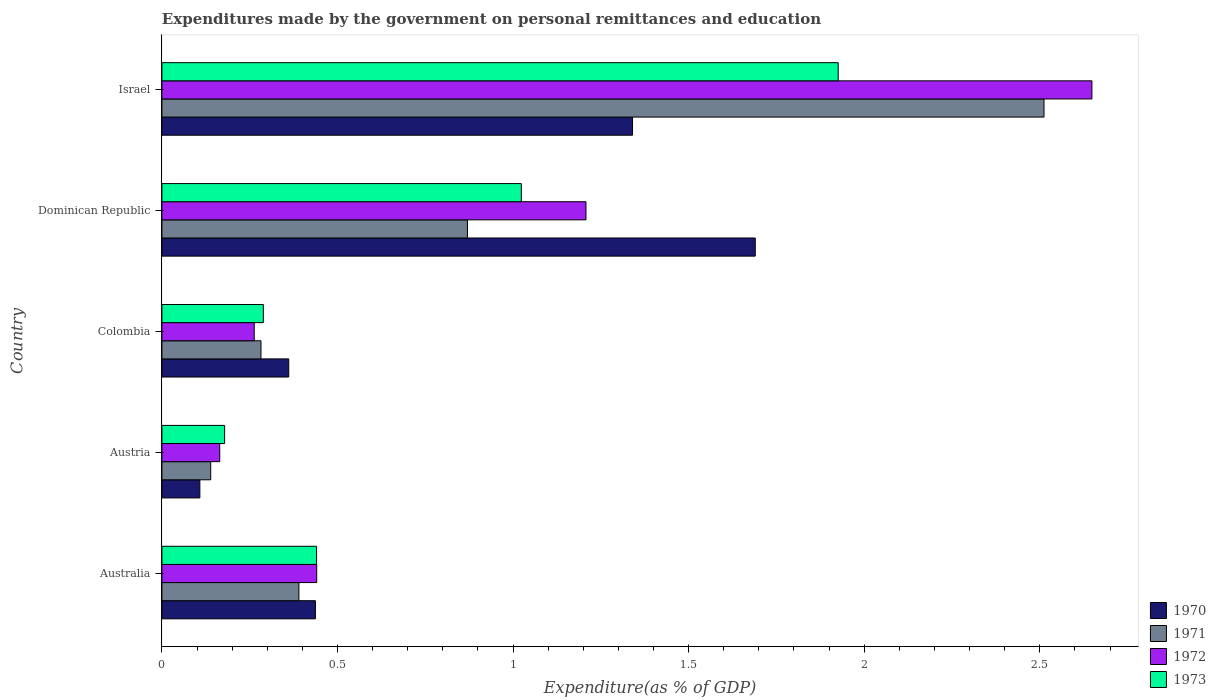How many groups of bars are there?
Keep it short and to the point. 5. Are the number of bars per tick equal to the number of legend labels?
Provide a succinct answer. Yes. How many bars are there on the 3rd tick from the top?
Provide a succinct answer. 4. How many bars are there on the 5th tick from the bottom?
Ensure brevity in your answer.  4. What is the label of the 1st group of bars from the top?
Offer a terse response. Israel. In how many cases, is the number of bars for a given country not equal to the number of legend labels?
Ensure brevity in your answer.  0. What is the expenditures made by the government on personal remittances and education in 1973 in Colombia?
Provide a short and direct response. 0.29. Across all countries, what is the maximum expenditures made by the government on personal remittances and education in 1973?
Your response must be concise. 1.93. Across all countries, what is the minimum expenditures made by the government on personal remittances and education in 1972?
Make the answer very short. 0.16. In which country was the expenditures made by the government on personal remittances and education in 1970 minimum?
Make the answer very short. Austria. What is the total expenditures made by the government on personal remittances and education in 1973 in the graph?
Your response must be concise. 3.86. What is the difference between the expenditures made by the government on personal remittances and education in 1971 in Austria and that in Israel?
Offer a very short reply. -2.37. What is the difference between the expenditures made by the government on personal remittances and education in 1973 in Australia and the expenditures made by the government on personal remittances and education in 1970 in Colombia?
Your answer should be very brief. 0.08. What is the average expenditures made by the government on personal remittances and education in 1973 per country?
Your answer should be compact. 0.77. What is the difference between the expenditures made by the government on personal remittances and education in 1971 and expenditures made by the government on personal remittances and education in 1970 in Austria?
Your answer should be very brief. 0.03. In how many countries, is the expenditures made by the government on personal remittances and education in 1972 greater than 0.9 %?
Offer a terse response. 2. What is the ratio of the expenditures made by the government on personal remittances and education in 1970 in Australia to that in Israel?
Provide a short and direct response. 0.33. Is the difference between the expenditures made by the government on personal remittances and education in 1971 in Australia and Dominican Republic greater than the difference between the expenditures made by the government on personal remittances and education in 1970 in Australia and Dominican Republic?
Offer a terse response. Yes. What is the difference between the highest and the second highest expenditures made by the government on personal remittances and education in 1971?
Make the answer very short. 1.64. What is the difference between the highest and the lowest expenditures made by the government on personal remittances and education in 1971?
Provide a short and direct response. 2.37. Is the sum of the expenditures made by the government on personal remittances and education in 1970 in Austria and Dominican Republic greater than the maximum expenditures made by the government on personal remittances and education in 1971 across all countries?
Your answer should be compact. No. Is it the case that in every country, the sum of the expenditures made by the government on personal remittances and education in 1971 and expenditures made by the government on personal remittances and education in 1970 is greater than the expenditures made by the government on personal remittances and education in 1972?
Your response must be concise. Yes. What is the difference between two consecutive major ticks on the X-axis?
Provide a short and direct response. 0.5. Are the values on the major ticks of X-axis written in scientific E-notation?
Give a very brief answer. No. Does the graph contain any zero values?
Offer a very short reply. No. Does the graph contain grids?
Your response must be concise. No. How are the legend labels stacked?
Offer a terse response. Vertical. What is the title of the graph?
Ensure brevity in your answer.  Expenditures made by the government on personal remittances and education. What is the label or title of the X-axis?
Ensure brevity in your answer.  Expenditure(as % of GDP). What is the Expenditure(as % of GDP) of 1970 in Australia?
Keep it short and to the point. 0.44. What is the Expenditure(as % of GDP) in 1971 in Australia?
Offer a very short reply. 0.39. What is the Expenditure(as % of GDP) of 1972 in Australia?
Your answer should be compact. 0.44. What is the Expenditure(as % of GDP) in 1973 in Australia?
Provide a short and direct response. 0.44. What is the Expenditure(as % of GDP) of 1970 in Austria?
Give a very brief answer. 0.11. What is the Expenditure(as % of GDP) of 1971 in Austria?
Your answer should be compact. 0.14. What is the Expenditure(as % of GDP) of 1972 in Austria?
Ensure brevity in your answer.  0.16. What is the Expenditure(as % of GDP) of 1973 in Austria?
Offer a terse response. 0.18. What is the Expenditure(as % of GDP) in 1970 in Colombia?
Give a very brief answer. 0.36. What is the Expenditure(as % of GDP) of 1971 in Colombia?
Your answer should be very brief. 0.28. What is the Expenditure(as % of GDP) of 1972 in Colombia?
Give a very brief answer. 0.26. What is the Expenditure(as % of GDP) of 1973 in Colombia?
Your answer should be compact. 0.29. What is the Expenditure(as % of GDP) of 1970 in Dominican Republic?
Offer a terse response. 1.69. What is the Expenditure(as % of GDP) of 1971 in Dominican Republic?
Make the answer very short. 0.87. What is the Expenditure(as % of GDP) of 1972 in Dominican Republic?
Your answer should be compact. 1.21. What is the Expenditure(as % of GDP) in 1973 in Dominican Republic?
Give a very brief answer. 1.02. What is the Expenditure(as % of GDP) of 1970 in Israel?
Provide a short and direct response. 1.34. What is the Expenditure(as % of GDP) of 1971 in Israel?
Offer a terse response. 2.51. What is the Expenditure(as % of GDP) of 1972 in Israel?
Provide a short and direct response. 2.65. What is the Expenditure(as % of GDP) in 1973 in Israel?
Offer a terse response. 1.93. Across all countries, what is the maximum Expenditure(as % of GDP) of 1970?
Provide a short and direct response. 1.69. Across all countries, what is the maximum Expenditure(as % of GDP) of 1971?
Offer a very short reply. 2.51. Across all countries, what is the maximum Expenditure(as % of GDP) in 1972?
Ensure brevity in your answer.  2.65. Across all countries, what is the maximum Expenditure(as % of GDP) of 1973?
Provide a short and direct response. 1.93. Across all countries, what is the minimum Expenditure(as % of GDP) in 1970?
Offer a very short reply. 0.11. Across all countries, what is the minimum Expenditure(as % of GDP) in 1971?
Make the answer very short. 0.14. Across all countries, what is the minimum Expenditure(as % of GDP) of 1972?
Your response must be concise. 0.16. Across all countries, what is the minimum Expenditure(as % of GDP) in 1973?
Your answer should be very brief. 0.18. What is the total Expenditure(as % of GDP) in 1970 in the graph?
Provide a short and direct response. 3.94. What is the total Expenditure(as % of GDP) in 1971 in the graph?
Your answer should be compact. 4.19. What is the total Expenditure(as % of GDP) of 1972 in the graph?
Your answer should be compact. 4.72. What is the total Expenditure(as % of GDP) in 1973 in the graph?
Provide a short and direct response. 3.86. What is the difference between the Expenditure(as % of GDP) of 1970 in Australia and that in Austria?
Provide a short and direct response. 0.33. What is the difference between the Expenditure(as % of GDP) in 1971 in Australia and that in Austria?
Offer a very short reply. 0.25. What is the difference between the Expenditure(as % of GDP) of 1972 in Australia and that in Austria?
Keep it short and to the point. 0.28. What is the difference between the Expenditure(as % of GDP) of 1973 in Australia and that in Austria?
Give a very brief answer. 0.26. What is the difference between the Expenditure(as % of GDP) in 1970 in Australia and that in Colombia?
Your answer should be very brief. 0.08. What is the difference between the Expenditure(as % of GDP) of 1971 in Australia and that in Colombia?
Your answer should be very brief. 0.11. What is the difference between the Expenditure(as % of GDP) of 1972 in Australia and that in Colombia?
Ensure brevity in your answer.  0.18. What is the difference between the Expenditure(as % of GDP) of 1973 in Australia and that in Colombia?
Your response must be concise. 0.15. What is the difference between the Expenditure(as % of GDP) in 1970 in Australia and that in Dominican Republic?
Give a very brief answer. -1.25. What is the difference between the Expenditure(as % of GDP) of 1971 in Australia and that in Dominican Republic?
Offer a very short reply. -0.48. What is the difference between the Expenditure(as % of GDP) of 1972 in Australia and that in Dominican Republic?
Your answer should be very brief. -0.77. What is the difference between the Expenditure(as % of GDP) of 1973 in Australia and that in Dominican Republic?
Make the answer very short. -0.58. What is the difference between the Expenditure(as % of GDP) of 1970 in Australia and that in Israel?
Offer a very short reply. -0.9. What is the difference between the Expenditure(as % of GDP) of 1971 in Australia and that in Israel?
Offer a terse response. -2.12. What is the difference between the Expenditure(as % of GDP) in 1972 in Australia and that in Israel?
Make the answer very short. -2.21. What is the difference between the Expenditure(as % of GDP) of 1973 in Australia and that in Israel?
Provide a succinct answer. -1.49. What is the difference between the Expenditure(as % of GDP) of 1970 in Austria and that in Colombia?
Make the answer very short. -0.25. What is the difference between the Expenditure(as % of GDP) of 1971 in Austria and that in Colombia?
Offer a terse response. -0.14. What is the difference between the Expenditure(as % of GDP) in 1972 in Austria and that in Colombia?
Make the answer very short. -0.1. What is the difference between the Expenditure(as % of GDP) of 1973 in Austria and that in Colombia?
Provide a succinct answer. -0.11. What is the difference between the Expenditure(as % of GDP) of 1970 in Austria and that in Dominican Republic?
Your answer should be compact. -1.58. What is the difference between the Expenditure(as % of GDP) of 1971 in Austria and that in Dominican Republic?
Your answer should be compact. -0.73. What is the difference between the Expenditure(as % of GDP) in 1972 in Austria and that in Dominican Republic?
Your response must be concise. -1.04. What is the difference between the Expenditure(as % of GDP) in 1973 in Austria and that in Dominican Republic?
Provide a succinct answer. -0.84. What is the difference between the Expenditure(as % of GDP) in 1970 in Austria and that in Israel?
Your response must be concise. -1.23. What is the difference between the Expenditure(as % of GDP) of 1971 in Austria and that in Israel?
Ensure brevity in your answer.  -2.37. What is the difference between the Expenditure(as % of GDP) in 1972 in Austria and that in Israel?
Keep it short and to the point. -2.48. What is the difference between the Expenditure(as % of GDP) in 1973 in Austria and that in Israel?
Ensure brevity in your answer.  -1.75. What is the difference between the Expenditure(as % of GDP) in 1970 in Colombia and that in Dominican Republic?
Provide a succinct answer. -1.33. What is the difference between the Expenditure(as % of GDP) in 1971 in Colombia and that in Dominican Republic?
Your response must be concise. -0.59. What is the difference between the Expenditure(as % of GDP) of 1972 in Colombia and that in Dominican Republic?
Provide a short and direct response. -0.94. What is the difference between the Expenditure(as % of GDP) in 1973 in Colombia and that in Dominican Republic?
Your answer should be very brief. -0.73. What is the difference between the Expenditure(as % of GDP) in 1970 in Colombia and that in Israel?
Your response must be concise. -0.98. What is the difference between the Expenditure(as % of GDP) in 1971 in Colombia and that in Israel?
Your response must be concise. -2.23. What is the difference between the Expenditure(as % of GDP) in 1972 in Colombia and that in Israel?
Your answer should be very brief. -2.39. What is the difference between the Expenditure(as % of GDP) of 1973 in Colombia and that in Israel?
Your answer should be very brief. -1.64. What is the difference between the Expenditure(as % of GDP) of 1970 in Dominican Republic and that in Israel?
Offer a very short reply. 0.35. What is the difference between the Expenditure(as % of GDP) of 1971 in Dominican Republic and that in Israel?
Ensure brevity in your answer.  -1.64. What is the difference between the Expenditure(as % of GDP) of 1972 in Dominican Republic and that in Israel?
Provide a short and direct response. -1.44. What is the difference between the Expenditure(as % of GDP) in 1973 in Dominican Republic and that in Israel?
Ensure brevity in your answer.  -0.9. What is the difference between the Expenditure(as % of GDP) in 1970 in Australia and the Expenditure(as % of GDP) in 1971 in Austria?
Your response must be concise. 0.3. What is the difference between the Expenditure(as % of GDP) of 1970 in Australia and the Expenditure(as % of GDP) of 1972 in Austria?
Offer a very short reply. 0.27. What is the difference between the Expenditure(as % of GDP) in 1970 in Australia and the Expenditure(as % of GDP) in 1973 in Austria?
Your response must be concise. 0.26. What is the difference between the Expenditure(as % of GDP) in 1971 in Australia and the Expenditure(as % of GDP) in 1972 in Austria?
Your answer should be very brief. 0.23. What is the difference between the Expenditure(as % of GDP) in 1971 in Australia and the Expenditure(as % of GDP) in 1973 in Austria?
Your answer should be very brief. 0.21. What is the difference between the Expenditure(as % of GDP) in 1972 in Australia and the Expenditure(as % of GDP) in 1973 in Austria?
Your answer should be very brief. 0.26. What is the difference between the Expenditure(as % of GDP) of 1970 in Australia and the Expenditure(as % of GDP) of 1971 in Colombia?
Your answer should be compact. 0.15. What is the difference between the Expenditure(as % of GDP) of 1970 in Australia and the Expenditure(as % of GDP) of 1972 in Colombia?
Offer a terse response. 0.17. What is the difference between the Expenditure(as % of GDP) of 1970 in Australia and the Expenditure(as % of GDP) of 1973 in Colombia?
Your answer should be compact. 0.15. What is the difference between the Expenditure(as % of GDP) of 1971 in Australia and the Expenditure(as % of GDP) of 1972 in Colombia?
Your answer should be very brief. 0.13. What is the difference between the Expenditure(as % of GDP) in 1971 in Australia and the Expenditure(as % of GDP) in 1973 in Colombia?
Your response must be concise. 0.1. What is the difference between the Expenditure(as % of GDP) of 1972 in Australia and the Expenditure(as % of GDP) of 1973 in Colombia?
Give a very brief answer. 0.15. What is the difference between the Expenditure(as % of GDP) in 1970 in Australia and the Expenditure(as % of GDP) in 1971 in Dominican Republic?
Your response must be concise. -0.43. What is the difference between the Expenditure(as % of GDP) in 1970 in Australia and the Expenditure(as % of GDP) in 1972 in Dominican Republic?
Give a very brief answer. -0.77. What is the difference between the Expenditure(as % of GDP) of 1970 in Australia and the Expenditure(as % of GDP) of 1973 in Dominican Republic?
Offer a very short reply. -0.59. What is the difference between the Expenditure(as % of GDP) in 1971 in Australia and the Expenditure(as % of GDP) in 1972 in Dominican Republic?
Give a very brief answer. -0.82. What is the difference between the Expenditure(as % of GDP) in 1971 in Australia and the Expenditure(as % of GDP) in 1973 in Dominican Republic?
Ensure brevity in your answer.  -0.63. What is the difference between the Expenditure(as % of GDP) of 1972 in Australia and the Expenditure(as % of GDP) of 1973 in Dominican Republic?
Make the answer very short. -0.58. What is the difference between the Expenditure(as % of GDP) in 1970 in Australia and the Expenditure(as % of GDP) in 1971 in Israel?
Your answer should be very brief. -2.07. What is the difference between the Expenditure(as % of GDP) in 1970 in Australia and the Expenditure(as % of GDP) in 1972 in Israel?
Give a very brief answer. -2.21. What is the difference between the Expenditure(as % of GDP) of 1970 in Australia and the Expenditure(as % of GDP) of 1973 in Israel?
Ensure brevity in your answer.  -1.49. What is the difference between the Expenditure(as % of GDP) of 1971 in Australia and the Expenditure(as % of GDP) of 1972 in Israel?
Your answer should be compact. -2.26. What is the difference between the Expenditure(as % of GDP) of 1971 in Australia and the Expenditure(as % of GDP) of 1973 in Israel?
Provide a succinct answer. -1.54. What is the difference between the Expenditure(as % of GDP) in 1972 in Australia and the Expenditure(as % of GDP) in 1973 in Israel?
Your response must be concise. -1.49. What is the difference between the Expenditure(as % of GDP) in 1970 in Austria and the Expenditure(as % of GDP) in 1971 in Colombia?
Offer a very short reply. -0.17. What is the difference between the Expenditure(as % of GDP) in 1970 in Austria and the Expenditure(as % of GDP) in 1972 in Colombia?
Offer a terse response. -0.15. What is the difference between the Expenditure(as % of GDP) in 1970 in Austria and the Expenditure(as % of GDP) in 1973 in Colombia?
Ensure brevity in your answer.  -0.18. What is the difference between the Expenditure(as % of GDP) of 1971 in Austria and the Expenditure(as % of GDP) of 1972 in Colombia?
Provide a short and direct response. -0.12. What is the difference between the Expenditure(as % of GDP) of 1971 in Austria and the Expenditure(as % of GDP) of 1973 in Colombia?
Provide a succinct answer. -0.15. What is the difference between the Expenditure(as % of GDP) of 1972 in Austria and the Expenditure(as % of GDP) of 1973 in Colombia?
Keep it short and to the point. -0.12. What is the difference between the Expenditure(as % of GDP) in 1970 in Austria and the Expenditure(as % of GDP) in 1971 in Dominican Republic?
Offer a very short reply. -0.76. What is the difference between the Expenditure(as % of GDP) of 1970 in Austria and the Expenditure(as % of GDP) of 1972 in Dominican Republic?
Give a very brief answer. -1.1. What is the difference between the Expenditure(as % of GDP) in 1970 in Austria and the Expenditure(as % of GDP) in 1973 in Dominican Republic?
Provide a short and direct response. -0.92. What is the difference between the Expenditure(as % of GDP) in 1971 in Austria and the Expenditure(as % of GDP) in 1972 in Dominican Republic?
Your answer should be very brief. -1.07. What is the difference between the Expenditure(as % of GDP) of 1971 in Austria and the Expenditure(as % of GDP) of 1973 in Dominican Republic?
Your answer should be very brief. -0.88. What is the difference between the Expenditure(as % of GDP) of 1972 in Austria and the Expenditure(as % of GDP) of 1973 in Dominican Republic?
Make the answer very short. -0.86. What is the difference between the Expenditure(as % of GDP) in 1970 in Austria and the Expenditure(as % of GDP) in 1971 in Israel?
Provide a short and direct response. -2.4. What is the difference between the Expenditure(as % of GDP) of 1970 in Austria and the Expenditure(as % of GDP) of 1972 in Israel?
Ensure brevity in your answer.  -2.54. What is the difference between the Expenditure(as % of GDP) in 1970 in Austria and the Expenditure(as % of GDP) in 1973 in Israel?
Make the answer very short. -1.82. What is the difference between the Expenditure(as % of GDP) of 1971 in Austria and the Expenditure(as % of GDP) of 1972 in Israel?
Your response must be concise. -2.51. What is the difference between the Expenditure(as % of GDP) of 1971 in Austria and the Expenditure(as % of GDP) of 1973 in Israel?
Offer a very short reply. -1.79. What is the difference between the Expenditure(as % of GDP) in 1972 in Austria and the Expenditure(as % of GDP) in 1973 in Israel?
Your answer should be very brief. -1.76. What is the difference between the Expenditure(as % of GDP) of 1970 in Colombia and the Expenditure(as % of GDP) of 1971 in Dominican Republic?
Keep it short and to the point. -0.51. What is the difference between the Expenditure(as % of GDP) in 1970 in Colombia and the Expenditure(as % of GDP) in 1972 in Dominican Republic?
Offer a terse response. -0.85. What is the difference between the Expenditure(as % of GDP) of 1970 in Colombia and the Expenditure(as % of GDP) of 1973 in Dominican Republic?
Keep it short and to the point. -0.66. What is the difference between the Expenditure(as % of GDP) in 1971 in Colombia and the Expenditure(as % of GDP) in 1972 in Dominican Republic?
Keep it short and to the point. -0.93. What is the difference between the Expenditure(as % of GDP) in 1971 in Colombia and the Expenditure(as % of GDP) in 1973 in Dominican Republic?
Keep it short and to the point. -0.74. What is the difference between the Expenditure(as % of GDP) in 1972 in Colombia and the Expenditure(as % of GDP) in 1973 in Dominican Republic?
Give a very brief answer. -0.76. What is the difference between the Expenditure(as % of GDP) of 1970 in Colombia and the Expenditure(as % of GDP) of 1971 in Israel?
Ensure brevity in your answer.  -2.15. What is the difference between the Expenditure(as % of GDP) in 1970 in Colombia and the Expenditure(as % of GDP) in 1972 in Israel?
Offer a very short reply. -2.29. What is the difference between the Expenditure(as % of GDP) in 1970 in Colombia and the Expenditure(as % of GDP) in 1973 in Israel?
Keep it short and to the point. -1.56. What is the difference between the Expenditure(as % of GDP) in 1971 in Colombia and the Expenditure(as % of GDP) in 1972 in Israel?
Make the answer very short. -2.37. What is the difference between the Expenditure(as % of GDP) of 1971 in Colombia and the Expenditure(as % of GDP) of 1973 in Israel?
Your response must be concise. -1.64. What is the difference between the Expenditure(as % of GDP) in 1972 in Colombia and the Expenditure(as % of GDP) in 1973 in Israel?
Give a very brief answer. -1.66. What is the difference between the Expenditure(as % of GDP) in 1970 in Dominican Republic and the Expenditure(as % of GDP) in 1971 in Israel?
Ensure brevity in your answer.  -0.82. What is the difference between the Expenditure(as % of GDP) of 1970 in Dominican Republic and the Expenditure(as % of GDP) of 1972 in Israel?
Provide a short and direct response. -0.96. What is the difference between the Expenditure(as % of GDP) of 1970 in Dominican Republic and the Expenditure(as % of GDP) of 1973 in Israel?
Your answer should be very brief. -0.24. What is the difference between the Expenditure(as % of GDP) of 1971 in Dominican Republic and the Expenditure(as % of GDP) of 1972 in Israel?
Offer a very short reply. -1.78. What is the difference between the Expenditure(as % of GDP) in 1971 in Dominican Republic and the Expenditure(as % of GDP) in 1973 in Israel?
Offer a very short reply. -1.06. What is the difference between the Expenditure(as % of GDP) of 1972 in Dominican Republic and the Expenditure(as % of GDP) of 1973 in Israel?
Provide a succinct answer. -0.72. What is the average Expenditure(as % of GDP) in 1970 per country?
Your answer should be compact. 0.79. What is the average Expenditure(as % of GDP) of 1971 per country?
Make the answer very short. 0.84. What is the average Expenditure(as % of GDP) of 1972 per country?
Offer a terse response. 0.94. What is the average Expenditure(as % of GDP) of 1973 per country?
Ensure brevity in your answer.  0.77. What is the difference between the Expenditure(as % of GDP) of 1970 and Expenditure(as % of GDP) of 1971 in Australia?
Provide a short and direct response. 0.05. What is the difference between the Expenditure(as % of GDP) of 1970 and Expenditure(as % of GDP) of 1972 in Australia?
Your response must be concise. -0. What is the difference between the Expenditure(as % of GDP) of 1970 and Expenditure(as % of GDP) of 1973 in Australia?
Your response must be concise. -0. What is the difference between the Expenditure(as % of GDP) in 1971 and Expenditure(as % of GDP) in 1972 in Australia?
Your answer should be very brief. -0.05. What is the difference between the Expenditure(as % of GDP) of 1971 and Expenditure(as % of GDP) of 1973 in Australia?
Give a very brief answer. -0.05. What is the difference between the Expenditure(as % of GDP) in 1972 and Expenditure(as % of GDP) in 1973 in Australia?
Ensure brevity in your answer.  0. What is the difference between the Expenditure(as % of GDP) in 1970 and Expenditure(as % of GDP) in 1971 in Austria?
Offer a terse response. -0.03. What is the difference between the Expenditure(as % of GDP) of 1970 and Expenditure(as % of GDP) of 1972 in Austria?
Your answer should be very brief. -0.06. What is the difference between the Expenditure(as % of GDP) of 1970 and Expenditure(as % of GDP) of 1973 in Austria?
Ensure brevity in your answer.  -0.07. What is the difference between the Expenditure(as % of GDP) of 1971 and Expenditure(as % of GDP) of 1972 in Austria?
Provide a succinct answer. -0.03. What is the difference between the Expenditure(as % of GDP) in 1971 and Expenditure(as % of GDP) in 1973 in Austria?
Your answer should be very brief. -0.04. What is the difference between the Expenditure(as % of GDP) in 1972 and Expenditure(as % of GDP) in 1973 in Austria?
Provide a succinct answer. -0.01. What is the difference between the Expenditure(as % of GDP) in 1970 and Expenditure(as % of GDP) in 1971 in Colombia?
Offer a very short reply. 0.08. What is the difference between the Expenditure(as % of GDP) in 1970 and Expenditure(as % of GDP) in 1972 in Colombia?
Provide a succinct answer. 0.1. What is the difference between the Expenditure(as % of GDP) of 1970 and Expenditure(as % of GDP) of 1973 in Colombia?
Ensure brevity in your answer.  0.07. What is the difference between the Expenditure(as % of GDP) in 1971 and Expenditure(as % of GDP) in 1972 in Colombia?
Offer a very short reply. 0.02. What is the difference between the Expenditure(as % of GDP) of 1971 and Expenditure(as % of GDP) of 1973 in Colombia?
Your answer should be compact. -0.01. What is the difference between the Expenditure(as % of GDP) of 1972 and Expenditure(as % of GDP) of 1973 in Colombia?
Offer a terse response. -0.03. What is the difference between the Expenditure(as % of GDP) of 1970 and Expenditure(as % of GDP) of 1971 in Dominican Republic?
Offer a terse response. 0.82. What is the difference between the Expenditure(as % of GDP) in 1970 and Expenditure(as % of GDP) in 1972 in Dominican Republic?
Your response must be concise. 0.48. What is the difference between the Expenditure(as % of GDP) of 1970 and Expenditure(as % of GDP) of 1973 in Dominican Republic?
Keep it short and to the point. 0.67. What is the difference between the Expenditure(as % of GDP) in 1971 and Expenditure(as % of GDP) in 1972 in Dominican Republic?
Give a very brief answer. -0.34. What is the difference between the Expenditure(as % of GDP) of 1971 and Expenditure(as % of GDP) of 1973 in Dominican Republic?
Provide a succinct answer. -0.15. What is the difference between the Expenditure(as % of GDP) of 1972 and Expenditure(as % of GDP) of 1973 in Dominican Republic?
Provide a short and direct response. 0.18. What is the difference between the Expenditure(as % of GDP) in 1970 and Expenditure(as % of GDP) in 1971 in Israel?
Your response must be concise. -1.17. What is the difference between the Expenditure(as % of GDP) of 1970 and Expenditure(as % of GDP) of 1972 in Israel?
Give a very brief answer. -1.31. What is the difference between the Expenditure(as % of GDP) of 1970 and Expenditure(as % of GDP) of 1973 in Israel?
Provide a short and direct response. -0.59. What is the difference between the Expenditure(as % of GDP) in 1971 and Expenditure(as % of GDP) in 1972 in Israel?
Make the answer very short. -0.14. What is the difference between the Expenditure(as % of GDP) of 1971 and Expenditure(as % of GDP) of 1973 in Israel?
Provide a short and direct response. 0.59. What is the difference between the Expenditure(as % of GDP) in 1972 and Expenditure(as % of GDP) in 1973 in Israel?
Give a very brief answer. 0.72. What is the ratio of the Expenditure(as % of GDP) of 1970 in Australia to that in Austria?
Keep it short and to the point. 4.04. What is the ratio of the Expenditure(as % of GDP) in 1971 in Australia to that in Austria?
Your response must be concise. 2.81. What is the ratio of the Expenditure(as % of GDP) of 1972 in Australia to that in Austria?
Keep it short and to the point. 2.68. What is the ratio of the Expenditure(as % of GDP) in 1973 in Australia to that in Austria?
Offer a very short reply. 2.47. What is the ratio of the Expenditure(as % of GDP) of 1970 in Australia to that in Colombia?
Ensure brevity in your answer.  1.21. What is the ratio of the Expenditure(as % of GDP) in 1971 in Australia to that in Colombia?
Keep it short and to the point. 1.38. What is the ratio of the Expenditure(as % of GDP) in 1972 in Australia to that in Colombia?
Your answer should be compact. 1.68. What is the ratio of the Expenditure(as % of GDP) of 1973 in Australia to that in Colombia?
Your response must be concise. 1.52. What is the ratio of the Expenditure(as % of GDP) in 1970 in Australia to that in Dominican Republic?
Provide a succinct answer. 0.26. What is the ratio of the Expenditure(as % of GDP) in 1971 in Australia to that in Dominican Republic?
Keep it short and to the point. 0.45. What is the ratio of the Expenditure(as % of GDP) in 1972 in Australia to that in Dominican Republic?
Provide a short and direct response. 0.37. What is the ratio of the Expenditure(as % of GDP) of 1973 in Australia to that in Dominican Republic?
Ensure brevity in your answer.  0.43. What is the ratio of the Expenditure(as % of GDP) in 1970 in Australia to that in Israel?
Provide a succinct answer. 0.33. What is the ratio of the Expenditure(as % of GDP) in 1971 in Australia to that in Israel?
Your answer should be compact. 0.16. What is the ratio of the Expenditure(as % of GDP) in 1972 in Australia to that in Israel?
Offer a very short reply. 0.17. What is the ratio of the Expenditure(as % of GDP) in 1973 in Australia to that in Israel?
Offer a terse response. 0.23. What is the ratio of the Expenditure(as % of GDP) of 1970 in Austria to that in Colombia?
Your answer should be very brief. 0.3. What is the ratio of the Expenditure(as % of GDP) of 1971 in Austria to that in Colombia?
Offer a terse response. 0.49. What is the ratio of the Expenditure(as % of GDP) of 1972 in Austria to that in Colombia?
Provide a succinct answer. 0.63. What is the ratio of the Expenditure(as % of GDP) in 1973 in Austria to that in Colombia?
Your answer should be very brief. 0.62. What is the ratio of the Expenditure(as % of GDP) of 1970 in Austria to that in Dominican Republic?
Keep it short and to the point. 0.06. What is the ratio of the Expenditure(as % of GDP) of 1971 in Austria to that in Dominican Republic?
Your answer should be very brief. 0.16. What is the ratio of the Expenditure(as % of GDP) of 1972 in Austria to that in Dominican Republic?
Your answer should be very brief. 0.14. What is the ratio of the Expenditure(as % of GDP) of 1973 in Austria to that in Dominican Republic?
Your response must be concise. 0.17. What is the ratio of the Expenditure(as % of GDP) in 1970 in Austria to that in Israel?
Your answer should be very brief. 0.08. What is the ratio of the Expenditure(as % of GDP) in 1971 in Austria to that in Israel?
Your answer should be very brief. 0.06. What is the ratio of the Expenditure(as % of GDP) of 1972 in Austria to that in Israel?
Offer a very short reply. 0.06. What is the ratio of the Expenditure(as % of GDP) of 1973 in Austria to that in Israel?
Provide a short and direct response. 0.09. What is the ratio of the Expenditure(as % of GDP) in 1970 in Colombia to that in Dominican Republic?
Ensure brevity in your answer.  0.21. What is the ratio of the Expenditure(as % of GDP) of 1971 in Colombia to that in Dominican Republic?
Your response must be concise. 0.32. What is the ratio of the Expenditure(as % of GDP) of 1972 in Colombia to that in Dominican Republic?
Make the answer very short. 0.22. What is the ratio of the Expenditure(as % of GDP) of 1973 in Colombia to that in Dominican Republic?
Make the answer very short. 0.28. What is the ratio of the Expenditure(as % of GDP) in 1970 in Colombia to that in Israel?
Offer a terse response. 0.27. What is the ratio of the Expenditure(as % of GDP) in 1971 in Colombia to that in Israel?
Offer a very short reply. 0.11. What is the ratio of the Expenditure(as % of GDP) in 1972 in Colombia to that in Israel?
Ensure brevity in your answer.  0.1. What is the ratio of the Expenditure(as % of GDP) in 1970 in Dominican Republic to that in Israel?
Your response must be concise. 1.26. What is the ratio of the Expenditure(as % of GDP) in 1971 in Dominican Republic to that in Israel?
Offer a terse response. 0.35. What is the ratio of the Expenditure(as % of GDP) of 1972 in Dominican Republic to that in Israel?
Your response must be concise. 0.46. What is the ratio of the Expenditure(as % of GDP) in 1973 in Dominican Republic to that in Israel?
Make the answer very short. 0.53. What is the difference between the highest and the second highest Expenditure(as % of GDP) in 1970?
Make the answer very short. 0.35. What is the difference between the highest and the second highest Expenditure(as % of GDP) of 1971?
Keep it short and to the point. 1.64. What is the difference between the highest and the second highest Expenditure(as % of GDP) in 1972?
Provide a short and direct response. 1.44. What is the difference between the highest and the second highest Expenditure(as % of GDP) in 1973?
Make the answer very short. 0.9. What is the difference between the highest and the lowest Expenditure(as % of GDP) in 1970?
Keep it short and to the point. 1.58. What is the difference between the highest and the lowest Expenditure(as % of GDP) in 1971?
Keep it short and to the point. 2.37. What is the difference between the highest and the lowest Expenditure(as % of GDP) of 1972?
Your response must be concise. 2.48. What is the difference between the highest and the lowest Expenditure(as % of GDP) in 1973?
Your response must be concise. 1.75. 